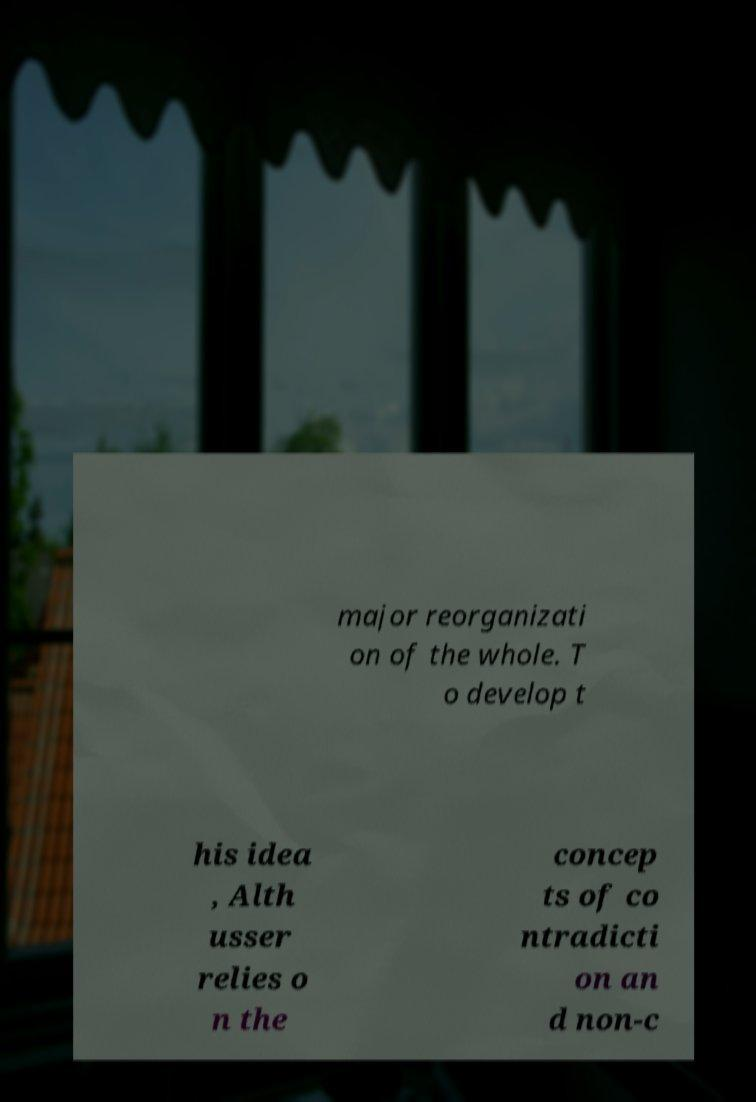There's text embedded in this image that I need extracted. Can you transcribe it verbatim? major reorganizati on of the whole. T o develop t his idea , Alth usser relies o n the concep ts of co ntradicti on an d non-c 